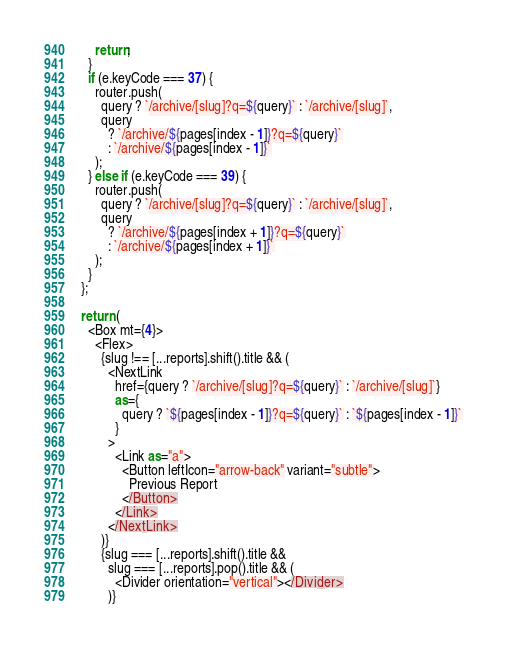<code> <loc_0><loc_0><loc_500><loc_500><_JavaScript_>      return;
    }
    if (e.keyCode === 37) {
      router.push(
        query ? `/archive/[slug]?q=${query}` : `/archive/[slug]`,
        query
          ? `/archive/${pages[index - 1]}?q=${query}`
          : `/archive/${pages[index - 1]}`
      );
    } else if (e.keyCode === 39) {
      router.push(
        query ? `/archive/[slug]?q=${query}` : `/archive/[slug]`,
        query
          ? `/archive/${pages[index + 1]}?q=${query}`
          : `/archive/${pages[index + 1]}`
      );
    }
  };

  return (
    <Box mt={4}>
      <Flex>
        {slug !== [...reports].shift().title && (
          <NextLink
            href={query ? `/archive/[slug]?q=${query}` : `/archive/[slug]`}
            as={
              query ? `${pages[index - 1]}?q=${query}` : `${pages[index - 1]}`
            }
          >
            <Link as="a">
              <Button leftIcon="arrow-back" variant="subtle">
                Previous Report
              </Button>
            </Link>
          </NextLink>
        )}
        {slug === [...reports].shift().title &&
          slug === [...reports].pop().title && (
            <Divider orientation="vertical"></Divider>
          )}</code> 